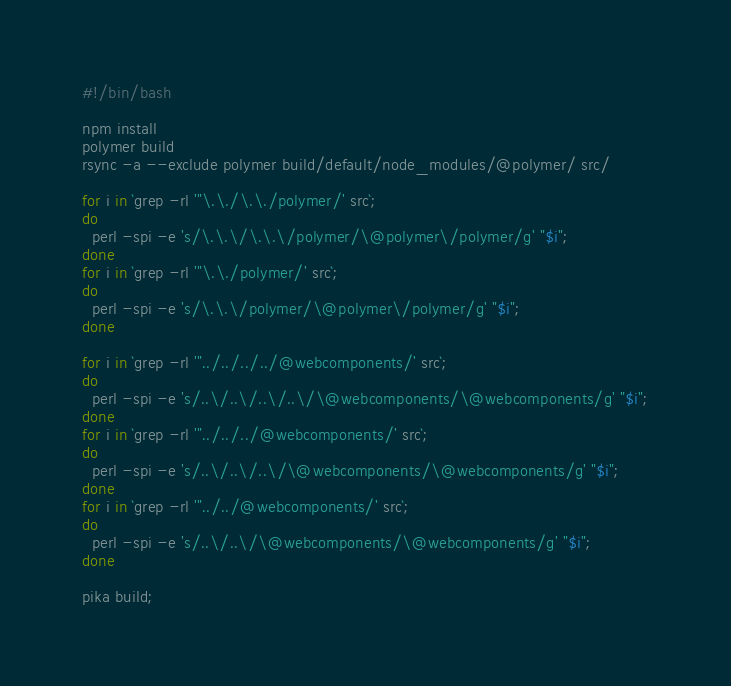<code> <loc_0><loc_0><loc_500><loc_500><_Bash_>#!/bin/bash

npm install
polymer build
rsync -a --exclude polymer build/default/node_modules/@polymer/ src/

for i in `grep -rl '"\.\./\.\./polymer/' src`;
do
  perl -spi -e 's/\.\.\/\.\.\/polymer/\@polymer\/polymer/g' "$i";
done
for i in `grep -rl '"\.\./polymer/' src`;
do
  perl -spi -e 's/\.\.\/polymer/\@polymer\/polymer/g' "$i";
done

for i in `grep -rl '"../../../../@webcomponents/' src`;
do
  perl -spi -e 's/..\/..\/..\/..\/\@webcomponents/\@webcomponents/g' "$i";
done
for i in `grep -rl '"../../../@webcomponents/' src`;
do
  perl -spi -e 's/..\/..\/..\/\@webcomponents/\@webcomponents/g' "$i";
done
for i in `grep -rl '"../../@webcomponents/' src`;
do
  perl -spi -e 's/..\/..\/\@webcomponents/\@webcomponents/g' "$i";
done

pika build;
</code> 